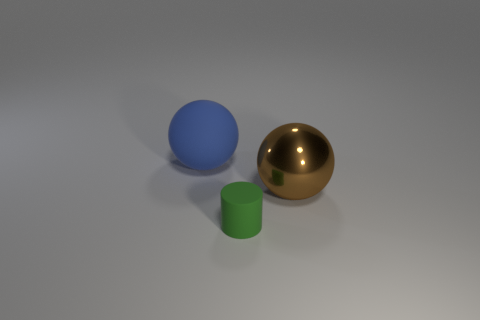Could you speculate on the size of these objects? While there isn't a frame of reference to determine the absolute size, we can infer the relative sizes. The green cylinder is smaller than the blue ball and the golden sphere appears the largest. The objects could range in size from a few centimeters to a several inches in diameter, which would be a common size for such display or decorative objects. 